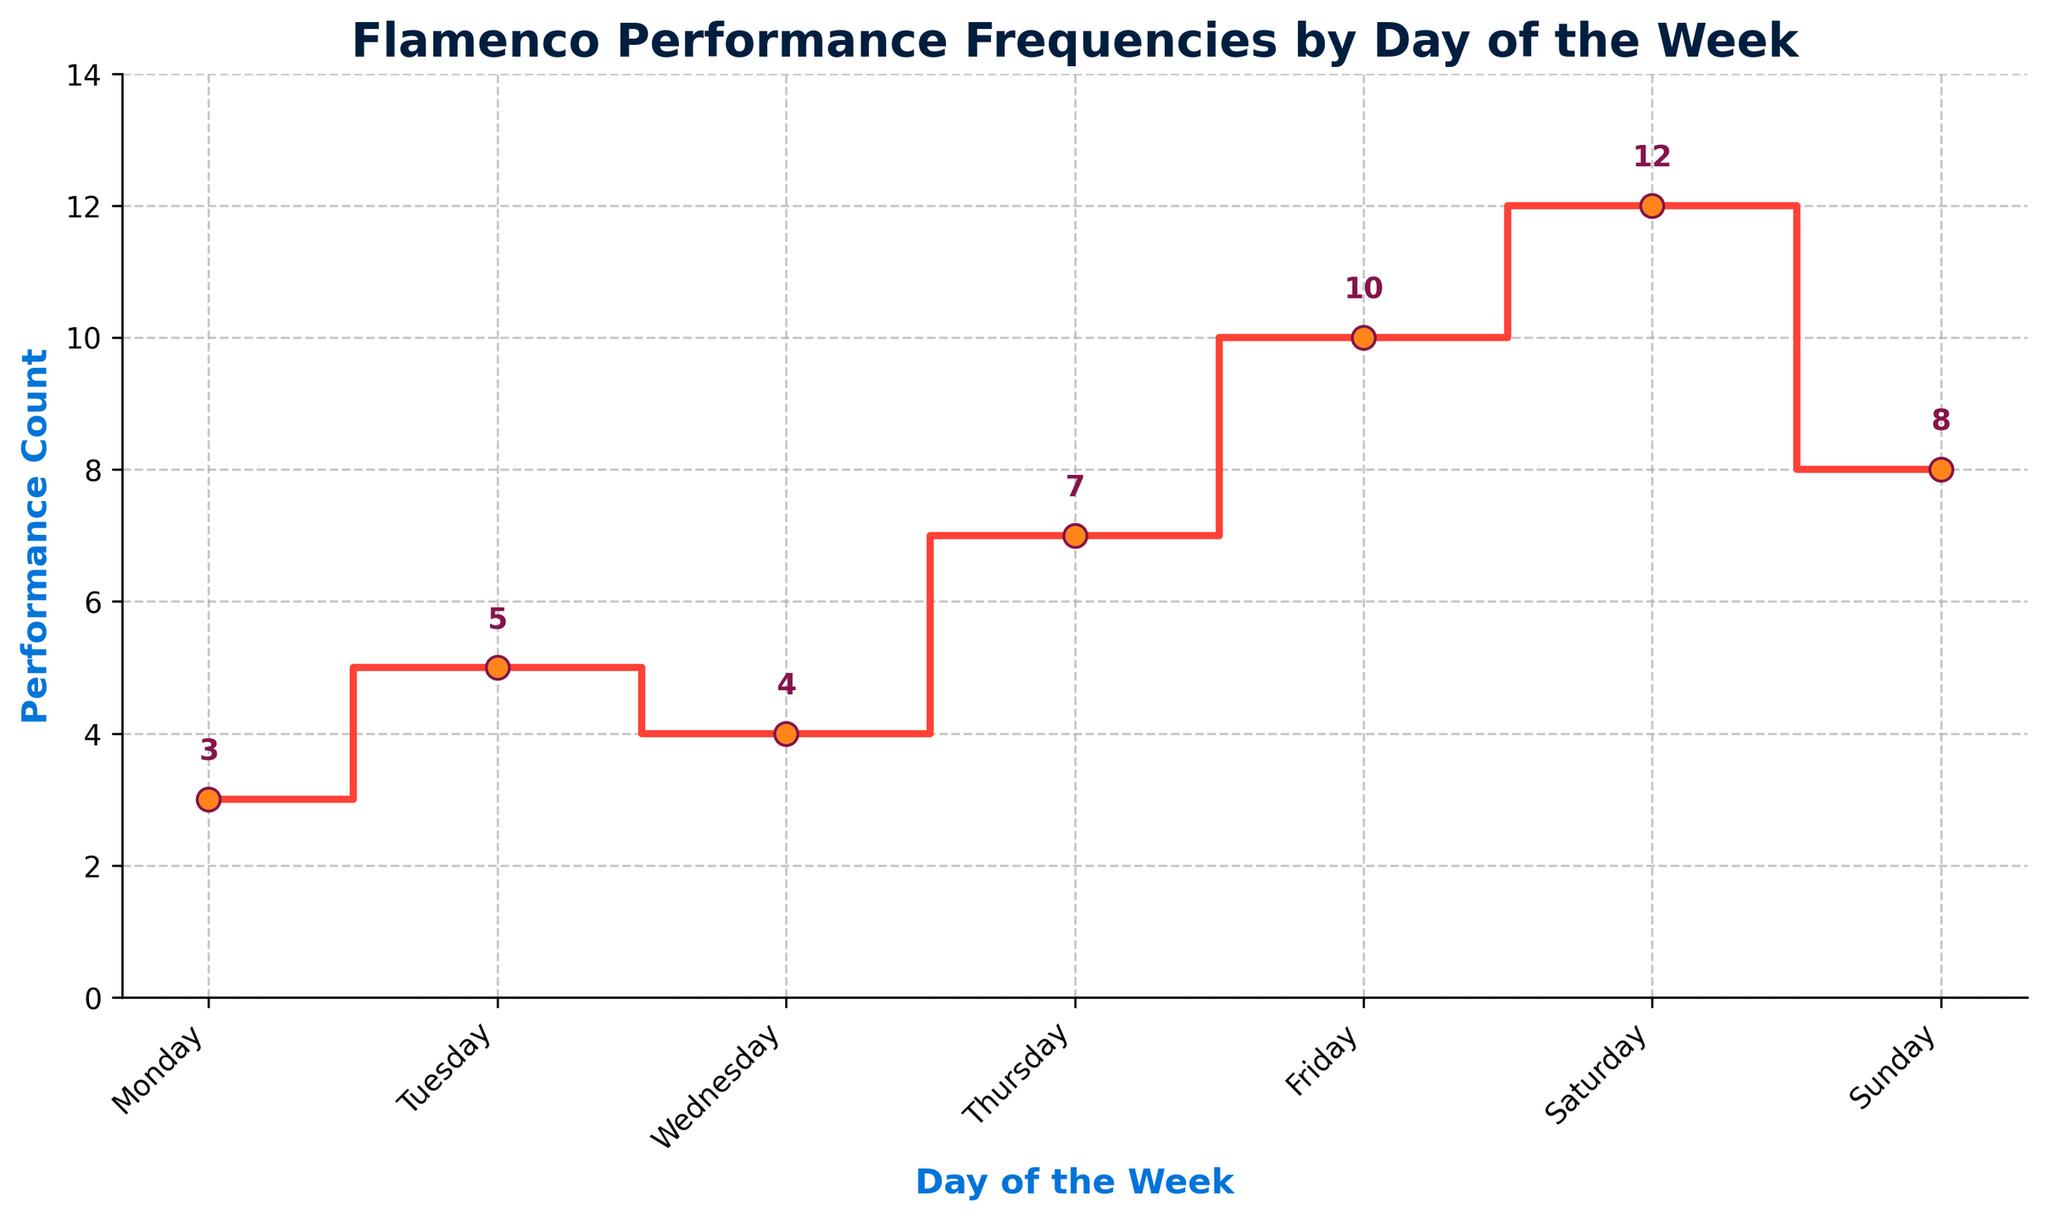What is the title of the plot? The title is usually placed at the top of the plot. In this case, it is written in bold and should describe the content of the plot.
Answer: Flamenco Performance Frequencies by Day of the Week What is the performance count on Tuesday? Find the marker for Tuesday on the x-axis, then look at the corresponding y-value indicated by the step and the label next to the marker.
Answer: 5 On which day is the performance count the highest? Look for the highest step on the y-axis and identify the corresponding marker on the x-axis.
Answer: Saturday Which day has the lowest performance count? Identify the smallest step value on the y-axis and trace it back to the x-axis.
Answer: Monday What are the performance counts for the weekends? Look at the markers for Saturday and Sunday and note their corresponding y-values from the step plot.
Answer: 12 (Saturday), 8 (Sunday) How much higher is the performance count on Friday compared to Monday? Subtract the performance count on Monday from the count on Friday: (10 - 3).
Answer: 7 What is the total performance count for Tuesday and Wednesday? Add the performance counts for Tuesday and Wednesday: (5 + 4).
Answer: 9 Compare the performance counts of Thursday and Sunday. Which is greater? Identify the y-values for Thursday and Sunday on the step plot and compare them.
Answer: Thursday What is the average performance count over the week? Sum the performance counts for all the days and divide by the number of days (7): (3 + 5 + 4 + 7 + 10 + 12 + 8)/7.
Answer: 7 How does the performance trend change from Monday through Sunday? Observe the trends in the step plot from left (Monday) to right (Sunday). Note if the performance count is generally increasing, decreasing, or has no particular trend.
Answer: Generally increasing 